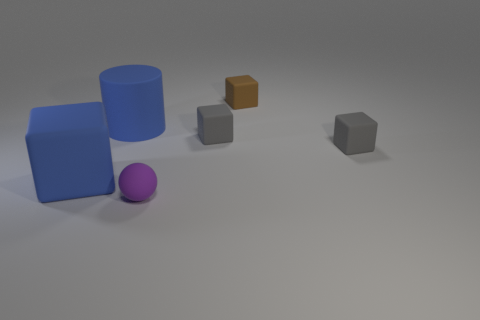What number of other things are the same shape as the small brown object?
Give a very brief answer. 3. There is a rubber cube that is to the left of the object in front of the large blue rubber block; what size is it?
Offer a very short reply. Large. Are any tiny red metallic balls visible?
Provide a succinct answer. No. How many brown blocks are right of the gray cube that is right of the small brown object?
Keep it short and to the point. 0. What is the shape of the big object to the left of the matte cylinder?
Provide a short and direct response. Cube. There is a object to the left of the blue object that is to the right of the cube that is on the left side of the small purple sphere; what is it made of?
Make the answer very short. Rubber. What number of other things are the same size as the purple matte thing?
Offer a terse response. 3. What is the material of the other big object that is the same shape as the brown rubber thing?
Offer a terse response. Rubber. The tiny matte sphere is what color?
Provide a succinct answer. Purple. The large object that is to the right of the blue rubber thing that is to the left of the big cylinder is what color?
Keep it short and to the point. Blue. 